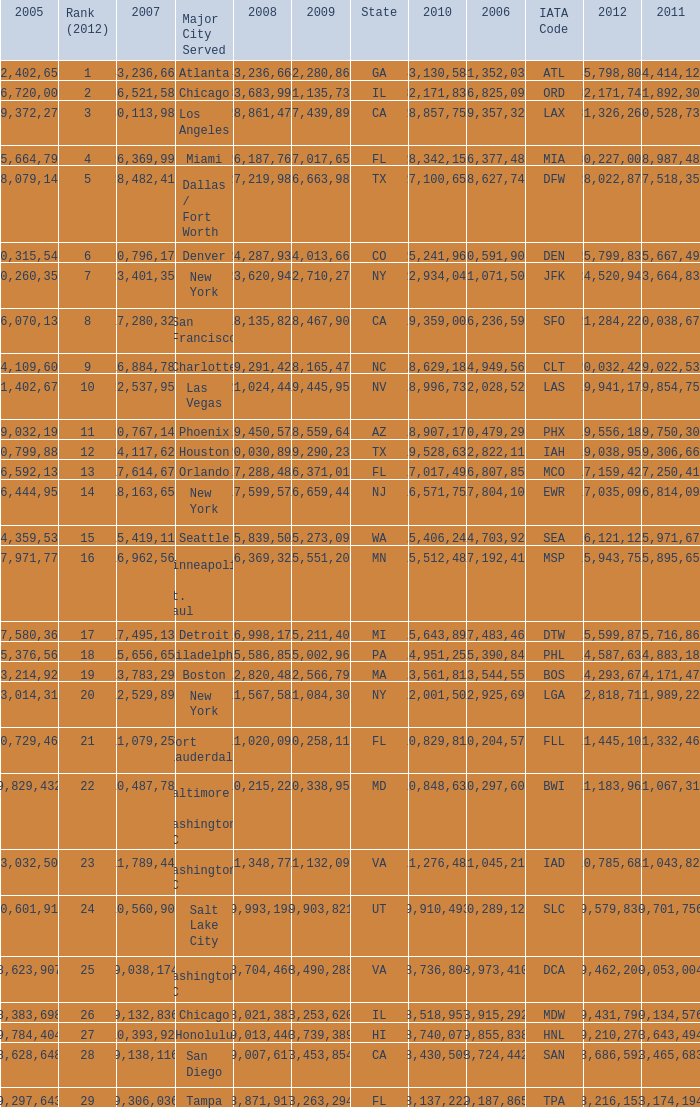For the IATA code of lax with 2009 less than 31,135,732 and 2011 less than 8,174,194, what is the sum of 2012? 0.0. 